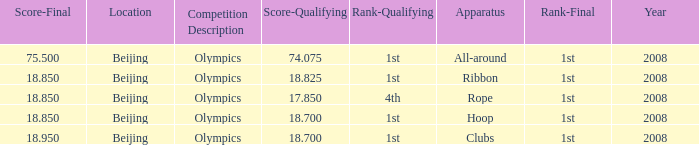What was her lowest final score with a qualifying score of 74.075? 75.5. 